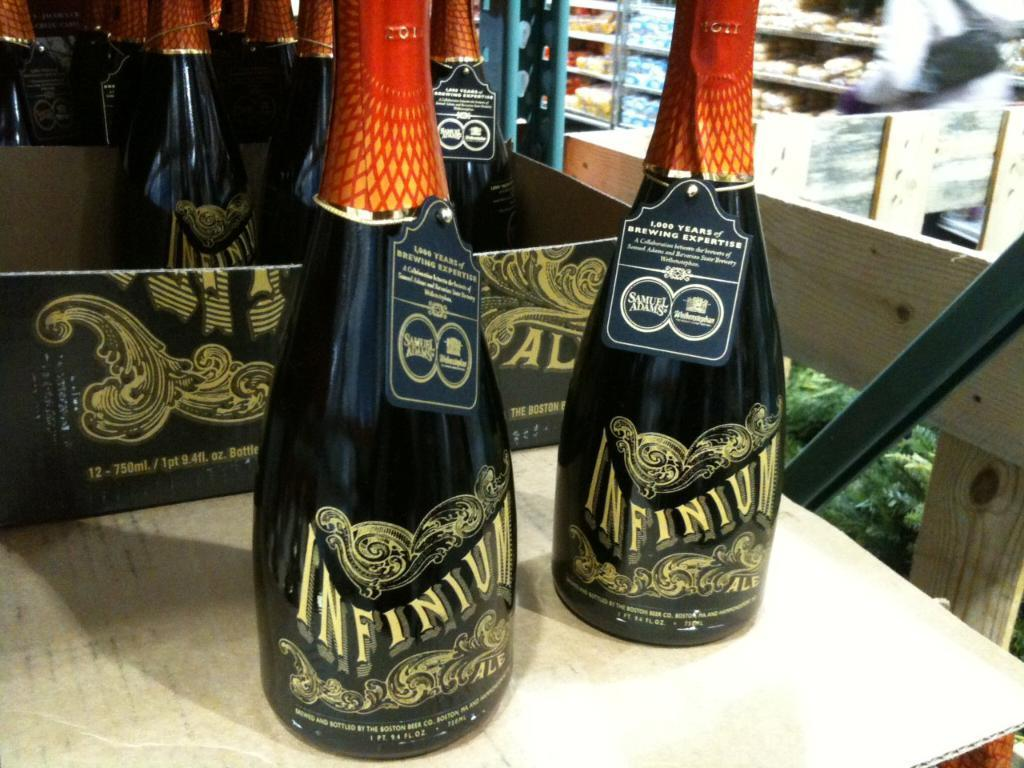Provide a one-sentence caption for the provided image. Two bottles of Infinium are displayed on a table. 